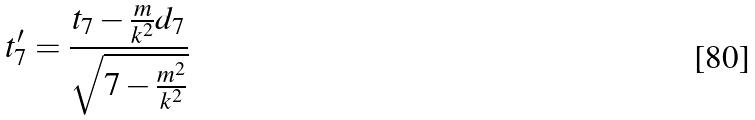Convert formula to latex. <formula><loc_0><loc_0><loc_500><loc_500>t _ { 7 } ^ { \prime } = \frac { t _ { 7 } - \frac { m } { k ^ { 2 } } d _ { 7 } } { \sqrt { 7 - \frac { m ^ { 2 } } { k ^ { 2 } } } }</formula> 